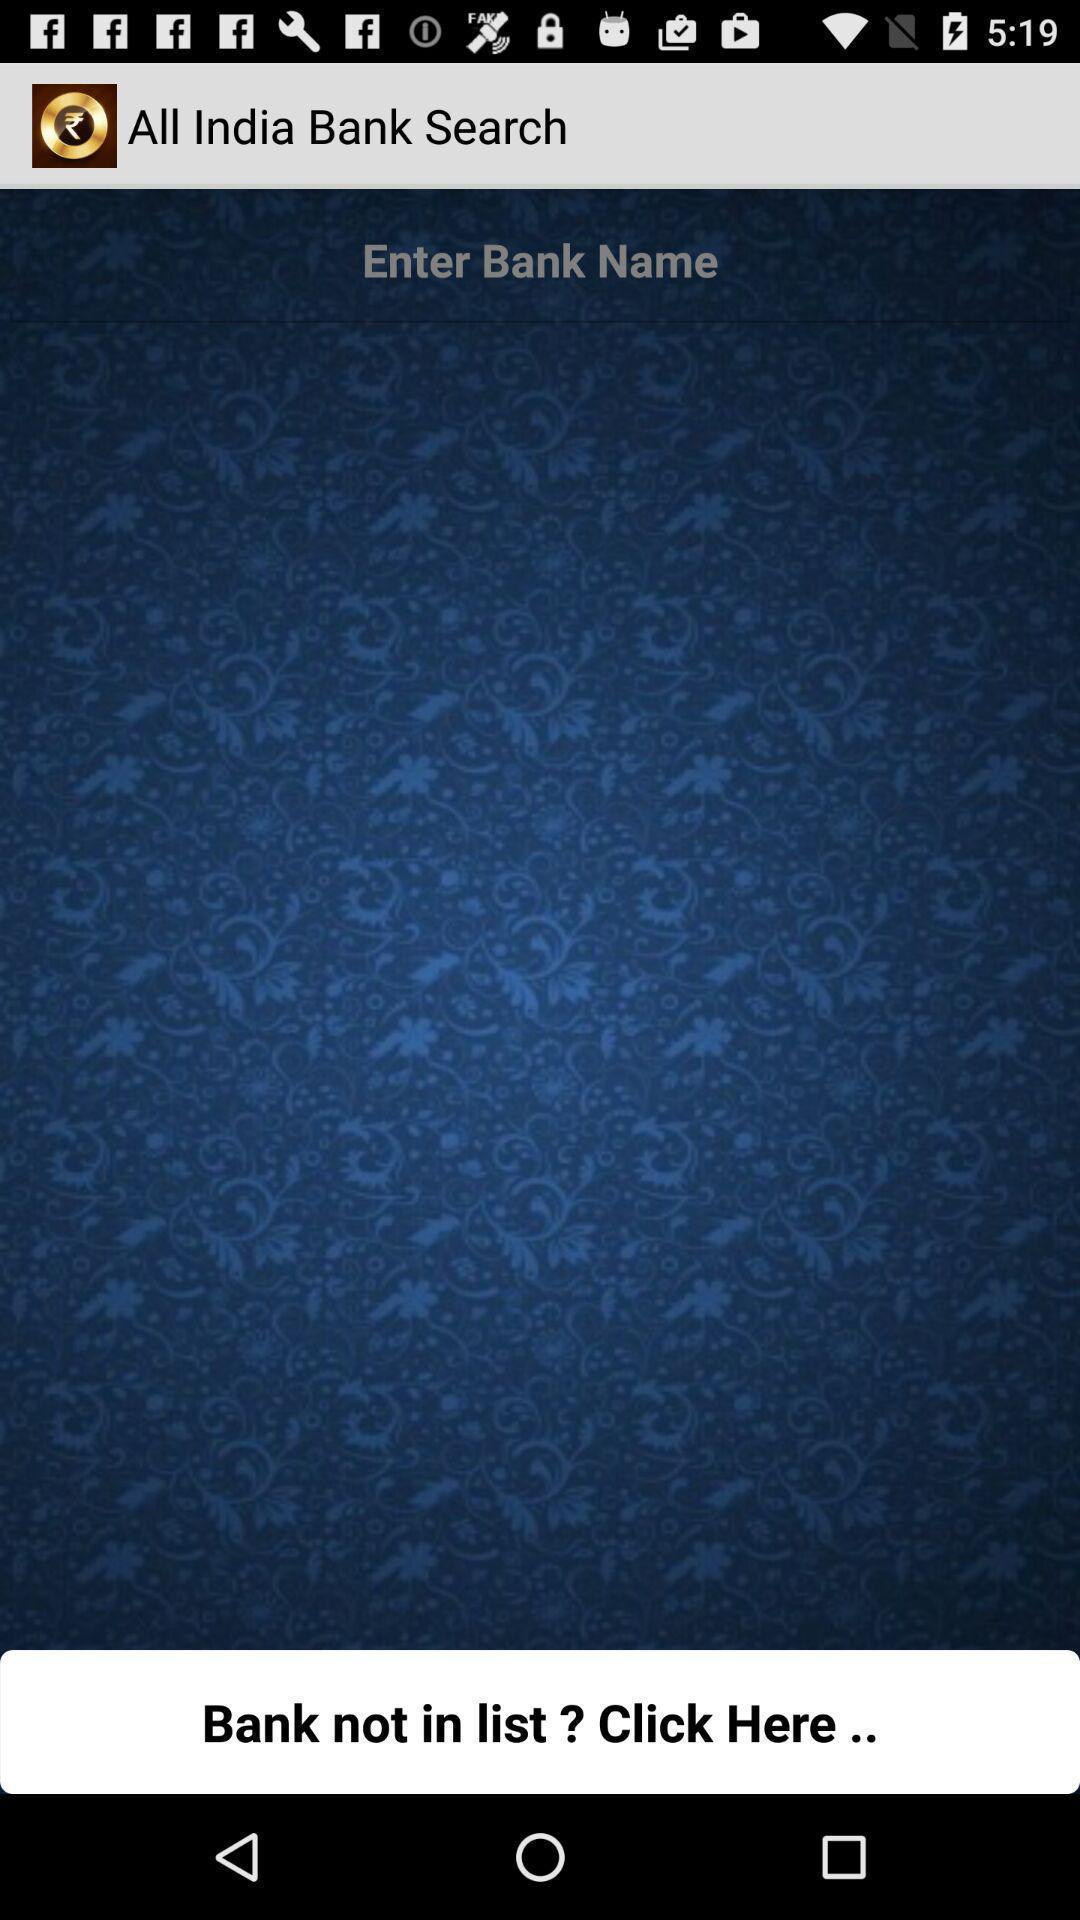Explain the elements present in this screenshot. Search page for searching a banks. 